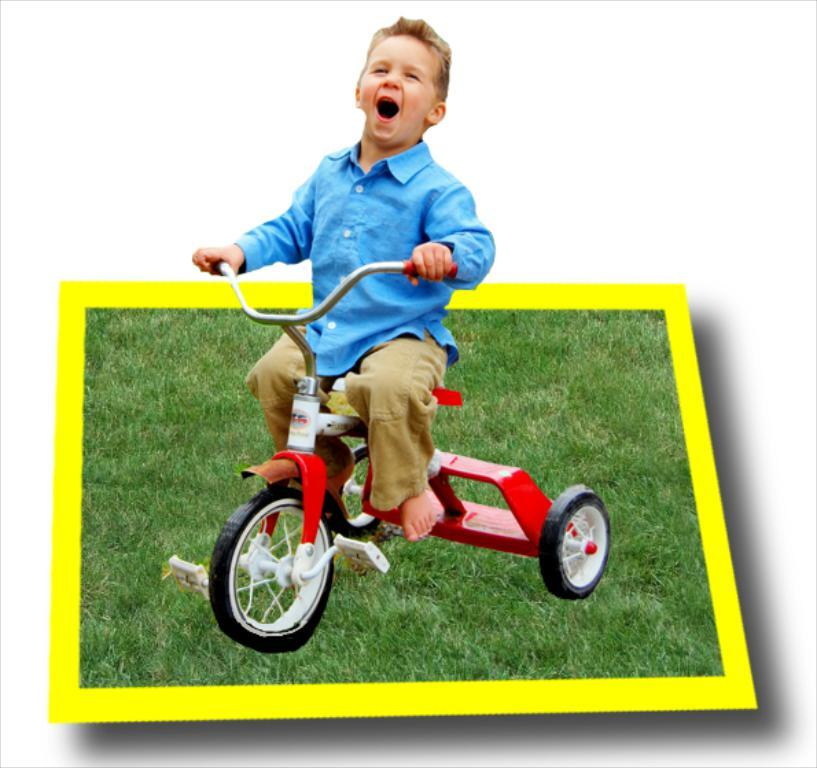What type of scene is depicted in the image? The image contains an animated scene. Can you describe the main character in the animated scene? There is a boy in the animated scene. What is the boy doing in the image? The boy is sitting on a bicycle. What type of environment is visible in the image? There is grass visible in the image. What type of game is the boy playing in the image? There is no game being played in the image; it is an animated scene of a boy sitting on a bicycle. How hot is the temperature in the image? The temperature is not mentioned in the image, as it is an animated scene. 